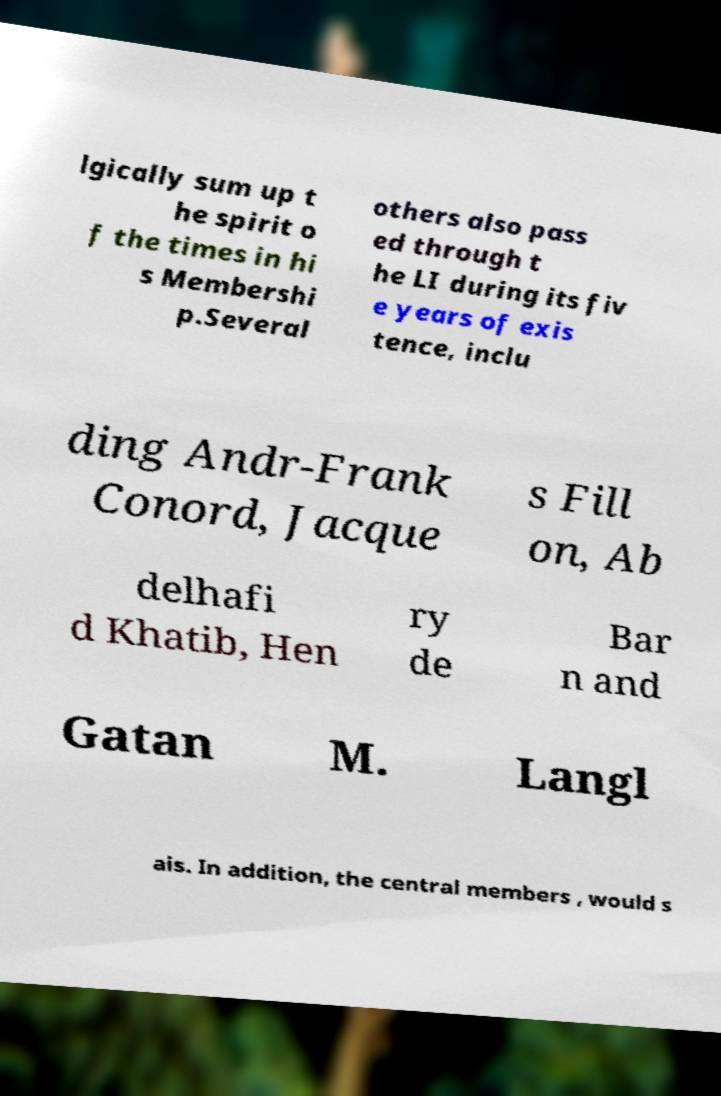What messages or text are displayed in this image? I need them in a readable, typed format. lgically sum up t he spirit o f the times in hi s Membershi p.Several others also pass ed through t he LI during its fiv e years of exis tence, inclu ding Andr-Frank Conord, Jacque s Fill on, Ab delhafi d Khatib, Hen ry de Bar n and Gatan M. Langl ais. In addition, the central members , would s 